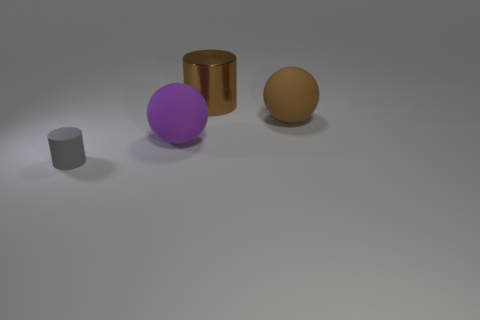What color is the metallic thing that is the same size as the brown rubber ball?
Provide a succinct answer. Brown. There is a large rubber thing to the right of the purple ball; is it the same shape as the thing that is in front of the purple object?
Offer a terse response. No. Is the number of objects behind the purple matte sphere the same as the number of large brown cylinders?
Your answer should be very brief. No. How many small cyan cubes have the same material as the big brown ball?
Offer a terse response. 0. There is a tiny object that is made of the same material as the large brown sphere; what color is it?
Ensure brevity in your answer.  Gray. Does the gray matte cylinder have the same size as the cylinder that is behind the gray cylinder?
Ensure brevity in your answer.  No. The gray rubber thing has what shape?
Provide a short and direct response. Cylinder. What number of small matte cylinders are the same color as the shiny cylinder?
Give a very brief answer. 0. What color is the other large matte object that is the same shape as the brown matte object?
Your answer should be very brief. Purple. There is a large rubber sphere right of the big purple rubber object; what number of small cylinders are left of it?
Ensure brevity in your answer.  1. 